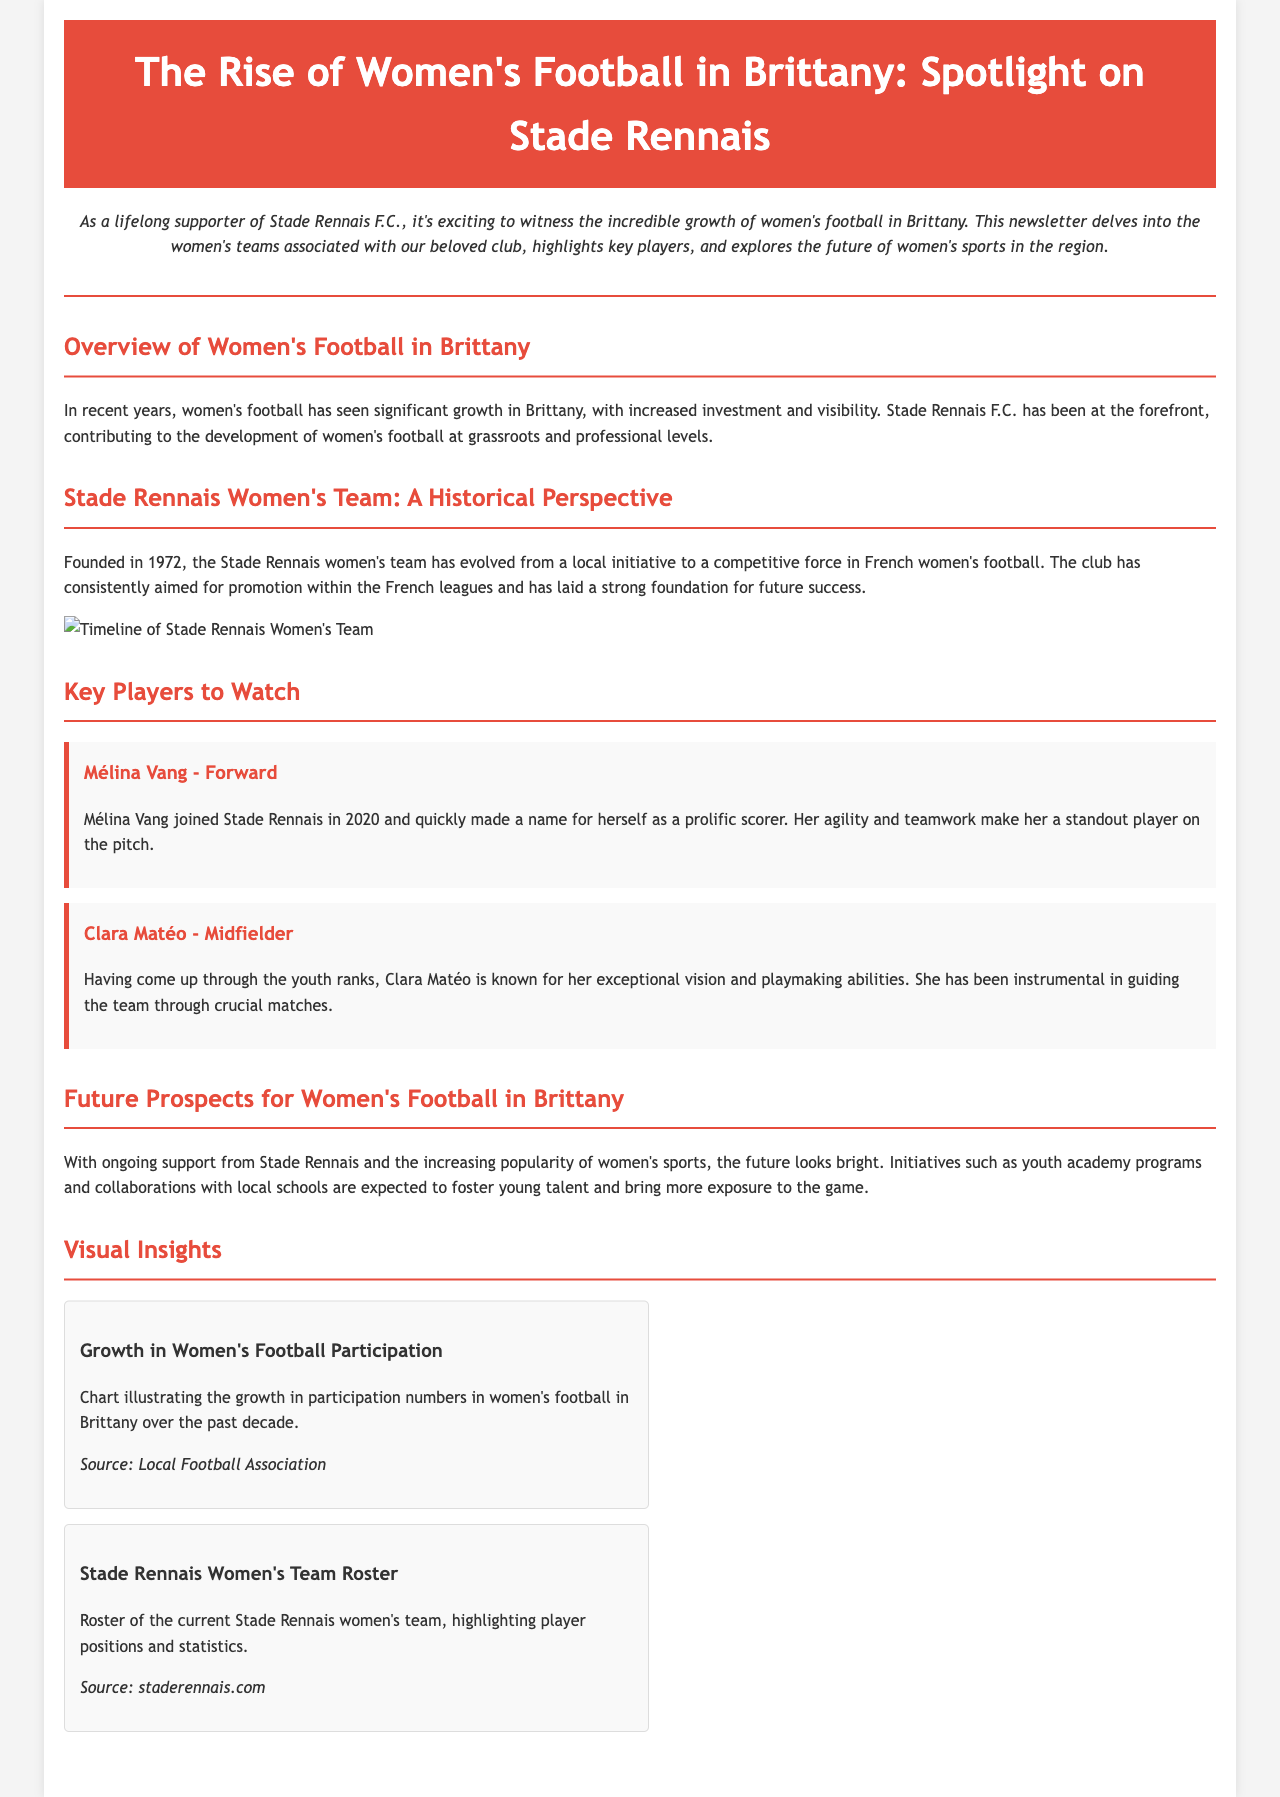What year was the Stade Rennais women's team founded? The document states that the Stade Rennais women's team was founded in 1972.
Answer: 1972 Who is a standout forward for Stade Rennais? The document mentions Mélina Vang as a prolific scorer and standout player.
Answer: Mélina Vang What does the timeline graphic illustrate? The timeline graphic shows the history of the Stade Rennais women's team since its inception.
Answer: Timeline of Stade Rennais Women's Team What is Clara Matéo known for? According to the document, Clara Matéo is known for her exceptional vision and playmaking abilities.
Answer: Exceptional vision and playmaking abilities What does the chart in the visual insights section depict? The chart illustrates the growth in participation numbers in women's football in Brittany over the past decade.
Answer: Growth in women's football participation 